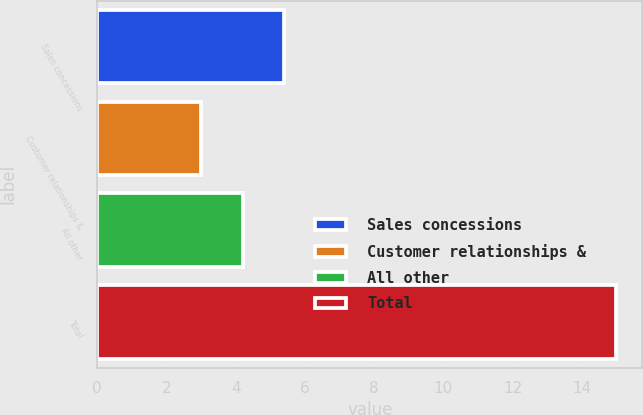Convert chart. <chart><loc_0><loc_0><loc_500><loc_500><bar_chart><fcel>Sales concessions<fcel>Customer relationships &<fcel>All other<fcel>Total<nl><fcel>5.4<fcel>3<fcel>4.2<fcel>15<nl></chart> 